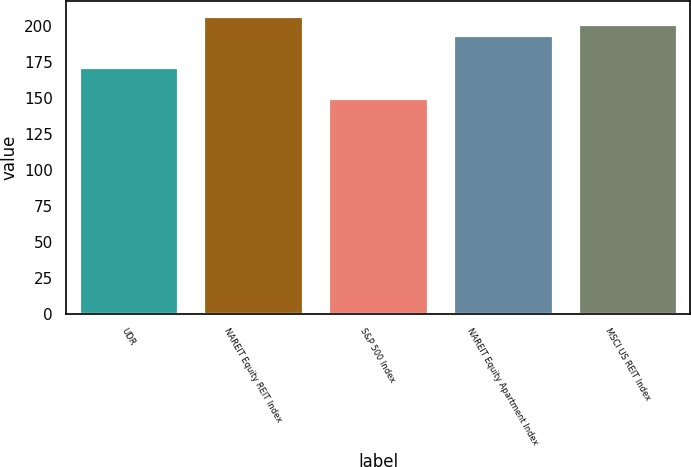Convert chart to OTSL. <chart><loc_0><loc_0><loc_500><loc_500><bar_chart><fcel>UDR<fcel>NAREIT Equity REIT Index<fcel>S&P 500 Index<fcel>NAREIT Equity Apartment Index<fcel>MSCI US REIT Index<nl><fcel>171.66<fcel>206.88<fcel>149.7<fcel>193.83<fcel>201.61<nl></chart> 